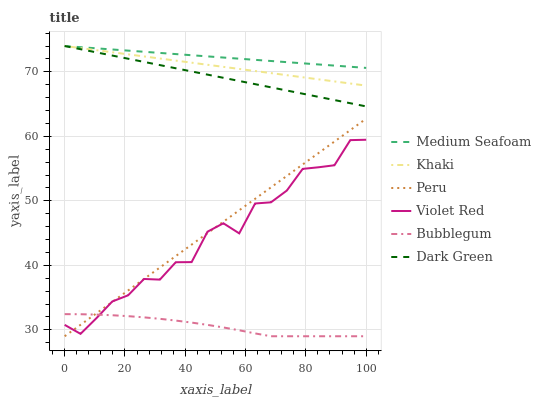Does Bubblegum have the minimum area under the curve?
Answer yes or no. Yes. Does Medium Seafoam have the maximum area under the curve?
Answer yes or no. Yes. Does Khaki have the minimum area under the curve?
Answer yes or no. No. Does Khaki have the maximum area under the curve?
Answer yes or no. No. Is Peru the smoothest?
Answer yes or no. Yes. Is Violet Red the roughest?
Answer yes or no. Yes. Is Khaki the smoothest?
Answer yes or no. No. Is Khaki the roughest?
Answer yes or no. No. Does Khaki have the lowest value?
Answer yes or no. No. Does Dark Green have the highest value?
Answer yes or no. Yes. Does Bubblegum have the highest value?
Answer yes or no. No. Is Bubblegum less than Medium Seafoam?
Answer yes or no. Yes. Is Khaki greater than Bubblegum?
Answer yes or no. Yes. Does Violet Red intersect Peru?
Answer yes or no. Yes. Is Violet Red less than Peru?
Answer yes or no. No. Is Violet Red greater than Peru?
Answer yes or no. No. Does Bubblegum intersect Medium Seafoam?
Answer yes or no. No. 